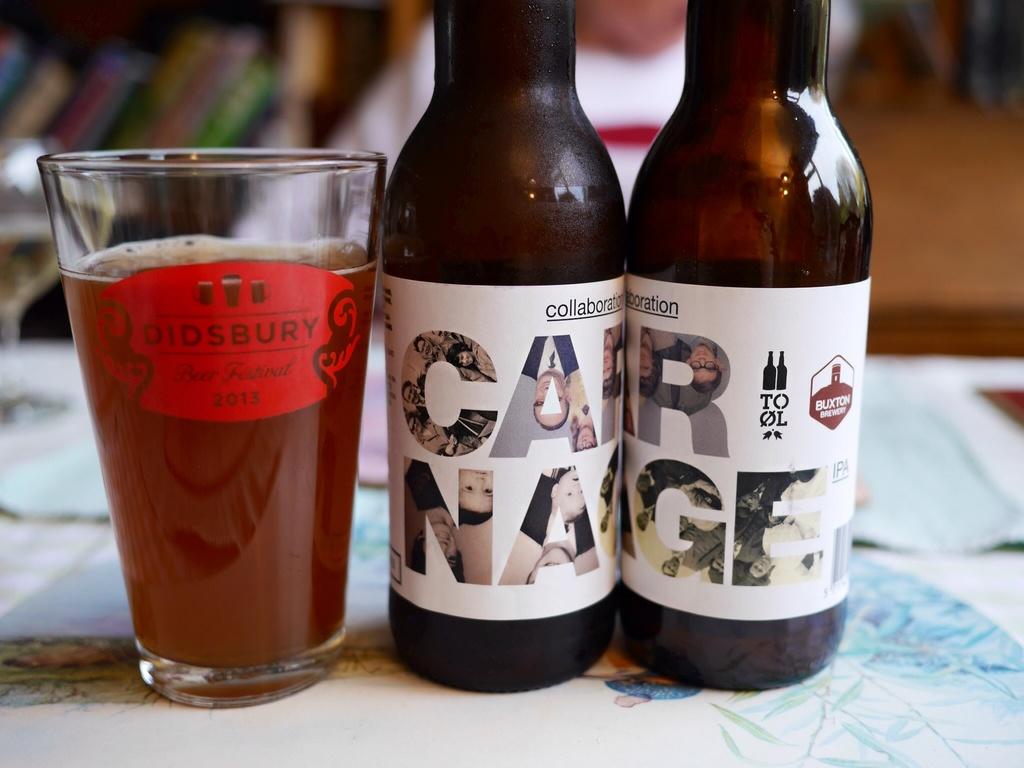Does the label on beer glass say didsbury beer festival?
Provide a succinct answer. Yes. 